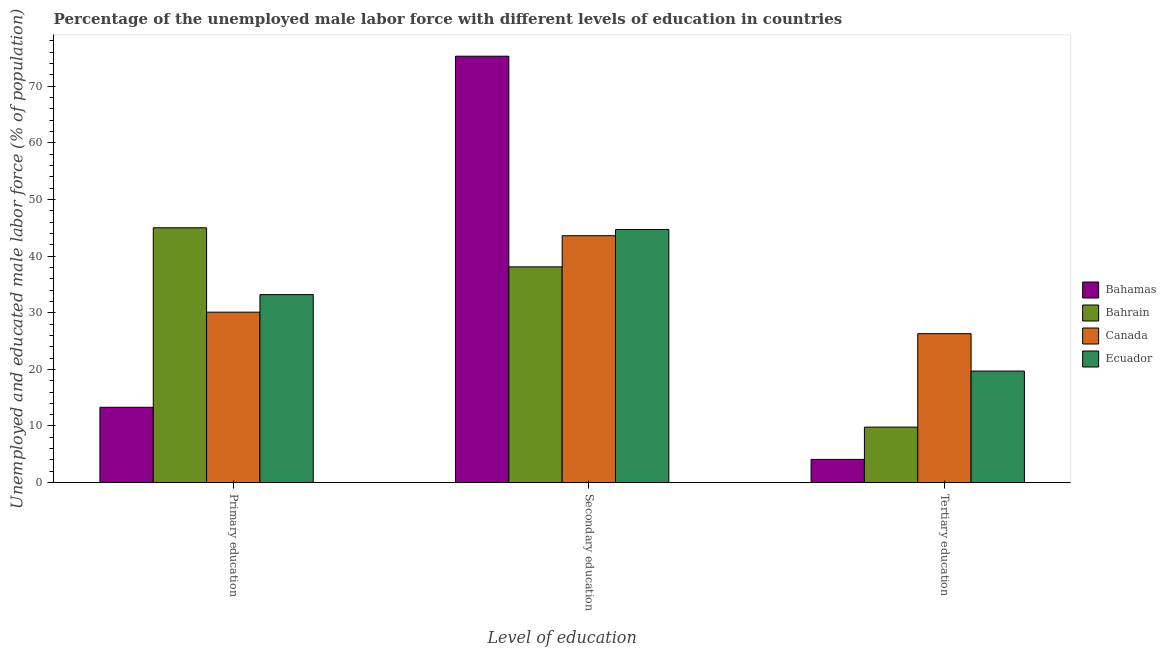How many different coloured bars are there?
Your answer should be very brief. 4. How many groups of bars are there?
Make the answer very short. 3. What is the percentage of male labor force who received tertiary education in Canada?
Your answer should be very brief. 26.3. Across all countries, what is the maximum percentage of male labor force who received secondary education?
Provide a short and direct response. 75.3. Across all countries, what is the minimum percentage of male labor force who received tertiary education?
Provide a succinct answer. 4.1. In which country was the percentage of male labor force who received secondary education maximum?
Provide a short and direct response. Bahamas. In which country was the percentage of male labor force who received tertiary education minimum?
Your answer should be very brief. Bahamas. What is the total percentage of male labor force who received secondary education in the graph?
Offer a terse response. 201.7. What is the difference between the percentage of male labor force who received tertiary education in Bahrain and that in Ecuador?
Your answer should be very brief. -9.9. What is the difference between the percentage of male labor force who received primary education in Ecuador and the percentage of male labor force who received secondary education in Bahamas?
Ensure brevity in your answer.  -42.1. What is the average percentage of male labor force who received secondary education per country?
Your answer should be compact. 50.43. What is the difference between the percentage of male labor force who received tertiary education and percentage of male labor force who received primary education in Canada?
Your answer should be very brief. -3.8. What is the ratio of the percentage of male labor force who received tertiary education in Canada to that in Bahamas?
Make the answer very short. 6.41. What is the difference between the highest and the second highest percentage of male labor force who received primary education?
Provide a short and direct response. 11.8. What is the difference between the highest and the lowest percentage of male labor force who received tertiary education?
Offer a very short reply. 22.2. In how many countries, is the percentage of male labor force who received tertiary education greater than the average percentage of male labor force who received tertiary education taken over all countries?
Your answer should be compact. 2. Is the sum of the percentage of male labor force who received primary education in Bahamas and Canada greater than the maximum percentage of male labor force who received tertiary education across all countries?
Provide a succinct answer. Yes. What does the 3rd bar from the left in Primary education represents?
Offer a very short reply. Canada. What does the 3rd bar from the right in Primary education represents?
Ensure brevity in your answer.  Bahrain. What is the difference between two consecutive major ticks on the Y-axis?
Ensure brevity in your answer.  10. Does the graph contain any zero values?
Your answer should be very brief. No. Where does the legend appear in the graph?
Ensure brevity in your answer.  Center right. How many legend labels are there?
Your answer should be compact. 4. How are the legend labels stacked?
Your answer should be compact. Vertical. What is the title of the graph?
Give a very brief answer. Percentage of the unemployed male labor force with different levels of education in countries. Does "Bahrain" appear as one of the legend labels in the graph?
Your answer should be very brief. Yes. What is the label or title of the X-axis?
Give a very brief answer. Level of education. What is the label or title of the Y-axis?
Your answer should be very brief. Unemployed and educated male labor force (% of population). What is the Unemployed and educated male labor force (% of population) of Bahamas in Primary education?
Your answer should be compact. 13.3. What is the Unemployed and educated male labor force (% of population) in Bahrain in Primary education?
Give a very brief answer. 45. What is the Unemployed and educated male labor force (% of population) in Canada in Primary education?
Offer a terse response. 30.1. What is the Unemployed and educated male labor force (% of population) in Ecuador in Primary education?
Ensure brevity in your answer.  33.2. What is the Unemployed and educated male labor force (% of population) in Bahamas in Secondary education?
Your answer should be compact. 75.3. What is the Unemployed and educated male labor force (% of population) of Bahrain in Secondary education?
Ensure brevity in your answer.  38.1. What is the Unemployed and educated male labor force (% of population) in Canada in Secondary education?
Your answer should be compact. 43.6. What is the Unemployed and educated male labor force (% of population) in Ecuador in Secondary education?
Keep it short and to the point. 44.7. What is the Unemployed and educated male labor force (% of population) in Bahamas in Tertiary education?
Your response must be concise. 4.1. What is the Unemployed and educated male labor force (% of population) of Bahrain in Tertiary education?
Keep it short and to the point. 9.8. What is the Unemployed and educated male labor force (% of population) of Canada in Tertiary education?
Your answer should be very brief. 26.3. What is the Unemployed and educated male labor force (% of population) of Ecuador in Tertiary education?
Offer a terse response. 19.7. Across all Level of education, what is the maximum Unemployed and educated male labor force (% of population) in Bahamas?
Your answer should be very brief. 75.3. Across all Level of education, what is the maximum Unemployed and educated male labor force (% of population) of Canada?
Ensure brevity in your answer.  43.6. Across all Level of education, what is the maximum Unemployed and educated male labor force (% of population) of Ecuador?
Your answer should be compact. 44.7. Across all Level of education, what is the minimum Unemployed and educated male labor force (% of population) of Bahamas?
Provide a short and direct response. 4.1. Across all Level of education, what is the minimum Unemployed and educated male labor force (% of population) in Bahrain?
Your answer should be compact. 9.8. Across all Level of education, what is the minimum Unemployed and educated male labor force (% of population) in Canada?
Make the answer very short. 26.3. Across all Level of education, what is the minimum Unemployed and educated male labor force (% of population) of Ecuador?
Ensure brevity in your answer.  19.7. What is the total Unemployed and educated male labor force (% of population) of Bahamas in the graph?
Keep it short and to the point. 92.7. What is the total Unemployed and educated male labor force (% of population) in Bahrain in the graph?
Provide a short and direct response. 92.9. What is the total Unemployed and educated male labor force (% of population) of Ecuador in the graph?
Your response must be concise. 97.6. What is the difference between the Unemployed and educated male labor force (% of population) in Bahamas in Primary education and that in Secondary education?
Your answer should be very brief. -62. What is the difference between the Unemployed and educated male labor force (% of population) of Bahrain in Primary education and that in Secondary education?
Give a very brief answer. 6.9. What is the difference between the Unemployed and educated male labor force (% of population) in Canada in Primary education and that in Secondary education?
Offer a very short reply. -13.5. What is the difference between the Unemployed and educated male labor force (% of population) in Bahamas in Primary education and that in Tertiary education?
Provide a succinct answer. 9.2. What is the difference between the Unemployed and educated male labor force (% of population) of Bahrain in Primary education and that in Tertiary education?
Offer a terse response. 35.2. What is the difference between the Unemployed and educated male labor force (% of population) of Bahamas in Secondary education and that in Tertiary education?
Keep it short and to the point. 71.2. What is the difference between the Unemployed and educated male labor force (% of population) in Bahrain in Secondary education and that in Tertiary education?
Your answer should be compact. 28.3. What is the difference between the Unemployed and educated male labor force (% of population) in Bahamas in Primary education and the Unemployed and educated male labor force (% of population) in Bahrain in Secondary education?
Make the answer very short. -24.8. What is the difference between the Unemployed and educated male labor force (% of population) in Bahamas in Primary education and the Unemployed and educated male labor force (% of population) in Canada in Secondary education?
Provide a short and direct response. -30.3. What is the difference between the Unemployed and educated male labor force (% of population) in Bahamas in Primary education and the Unemployed and educated male labor force (% of population) in Ecuador in Secondary education?
Make the answer very short. -31.4. What is the difference between the Unemployed and educated male labor force (% of population) in Bahrain in Primary education and the Unemployed and educated male labor force (% of population) in Ecuador in Secondary education?
Make the answer very short. 0.3. What is the difference between the Unemployed and educated male labor force (% of population) in Canada in Primary education and the Unemployed and educated male labor force (% of population) in Ecuador in Secondary education?
Provide a succinct answer. -14.6. What is the difference between the Unemployed and educated male labor force (% of population) in Bahamas in Primary education and the Unemployed and educated male labor force (% of population) in Bahrain in Tertiary education?
Give a very brief answer. 3.5. What is the difference between the Unemployed and educated male labor force (% of population) in Bahamas in Primary education and the Unemployed and educated male labor force (% of population) in Canada in Tertiary education?
Your answer should be very brief. -13. What is the difference between the Unemployed and educated male labor force (% of population) of Bahrain in Primary education and the Unemployed and educated male labor force (% of population) of Canada in Tertiary education?
Offer a terse response. 18.7. What is the difference between the Unemployed and educated male labor force (% of population) of Bahrain in Primary education and the Unemployed and educated male labor force (% of population) of Ecuador in Tertiary education?
Ensure brevity in your answer.  25.3. What is the difference between the Unemployed and educated male labor force (% of population) of Canada in Primary education and the Unemployed and educated male labor force (% of population) of Ecuador in Tertiary education?
Keep it short and to the point. 10.4. What is the difference between the Unemployed and educated male labor force (% of population) of Bahamas in Secondary education and the Unemployed and educated male labor force (% of population) of Bahrain in Tertiary education?
Provide a short and direct response. 65.5. What is the difference between the Unemployed and educated male labor force (% of population) in Bahamas in Secondary education and the Unemployed and educated male labor force (% of population) in Ecuador in Tertiary education?
Offer a very short reply. 55.6. What is the difference between the Unemployed and educated male labor force (% of population) of Bahrain in Secondary education and the Unemployed and educated male labor force (% of population) of Canada in Tertiary education?
Give a very brief answer. 11.8. What is the difference between the Unemployed and educated male labor force (% of population) in Canada in Secondary education and the Unemployed and educated male labor force (% of population) in Ecuador in Tertiary education?
Offer a very short reply. 23.9. What is the average Unemployed and educated male labor force (% of population) in Bahamas per Level of education?
Make the answer very short. 30.9. What is the average Unemployed and educated male labor force (% of population) of Bahrain per Level of education?
Your answer should be compact. 30.97. What is the average Unemployed and educated male labor force (% of population) in Canada per Level of education?
Keep it short and to the point. 33.33. What is the average Unemployed and educated male labor force (% of population) of Ecuador per Level of education?
Provide a succinct answer. 32.53. What is the difference between the Unemployed and educated male labor force (% of population) of Bahamas and Unemployed and educated male labor force (% of population) of Bahrain in Primary education?
Your answer should be compact. -31.7. What is the difference between the Unemployed and educated male labor force (% of population) of Bahamas and Unemployed and educated male labor force (% of population) of Canada in Primary education?
Give a very brief answer. -16.8. What is the difference between the Unemployed and educated male labor force (% of population) in Bahamas and Unemployed and educated male labor force (% of population) in Ecuador in Primary education?
Offer a terse response. -19.9. What is the difference between the Unemployed and educated male labor force (% of population) in Bahrain and Unemployed and educated male labor force (% of population) in Canada in Primary education?
Ensure brevity in your answer.  14.9. What is the difference between the Unemployed and educated male labor force (% of population) of Bahamas and Unemployed and educated male labor force (% of population) of Bahrain in Secondary education?
Make the answer very short. 37.2. What is the difference between the Unemployed and educated male labor force (% of population) of Bahamas and Unemployed and educated male labor force (% of population) of Canada in Secondary education?
Ensure brevity in your answer.  31.7. What is the difference between the Unemployed and educated male labor force (% of population) of Bahamas and Unemployed and educated male labor force (% of population) of Ecuador in Secondary education?
Give a very brief answer. 30.6. What is the difference between the Unemployed and educated male labor force (% of population) in Canada and Unemployed and educated male labor force (% of population) in Ecuador in Secondary education?
Give a very brief answer. -1.1. What is the difference between the Unemployed and educated male labor force (% of population) of Bahamas and Unemployed and educated male labor force (% of population) of Canada in Tertiary education?
Keep it short and to the point. -22.2. What is the difference between the Unemployed and educated male labor force (% of population) in Bahamas and Unemployed and educated male labor force (% of population) in Ecuador in Tertiary education?
Your answer should be very brief. -15.6. What is the difference between the Unemployed and educated male labor force (% of population) of Bahrain and Unemployed and educated male labor force (% of population) of Canada in Tertiary education?
Give a very brief answer. -16.5. What is the difference between the Unemployed and educated male labor force (% of population) of Bahrain and Unemployed and educated male labor force (% of population) of Ecuador in Tertiary education?
Provide a succinct answer. -9.9. What is the ratio of the Unemployed and educated male labor force (% of population) in Bahamas in Primary education to that in Secondary education?
Provide a short and direct response. 0.18. What is the ratio of the Unemployed and educated male labor force (% of population) of Bahrain in Primary education to that in Secondary education?
Make the answer very short. 1.18. What is the ratio of the Unemployed and educated male labor force (% of population) in Canada in Primary education to that in Secondary education?
Provide a short and direct response. 0.69. What is the ratio of the Unemployed and educated male labor force (% of population) in Ecuador in Primary education to that in Secondary education?
Offer a very short reply. 0.74. What is the ratio of the Unemployed and educated male labor force (% of population) in Bahamas in Primary education to that in Tertiary education?
Your answer should be compact. 3.24. What is the ratio of the Unemployed and educated male labor force (% of population) of Bahrain in Primary education to that in Tertiary education?
Offer a terse response. 4.59. What is the ratio of the Unemployed and educated male labor force (% of population) in Canada in Primary education to that in Tertiary education?
Keep it short and to the point. 1.14. What is the ratio of the Unemployed and educated male labor force (% of population) of Ecuador in Primary education to that in Tertiary education?
Keep it short and to the point. 1.69. What is the ratio of the Unemployed and educated male labor force (% of population) of Bahamas in Secondary education to that in Tertiary education?
Offer a terse response. 18.37. What is the ratio of the Unemployed and educated male labor force (% of population) of Bahrain in Secondary education to that in Tertiary education?
Your answer should be compact. 3.89. What is the ratio of the Unemployed and educated male labor force (% of population) in Canada in Secondary education to that in Tertiary education?
Your answer should be compact. 1.66. What is the ratio of the Unemployed and educated male labor force (% of population) of Ecuador in Secondary education to that in Tertiary education?
Your answer should be compact. 2.27. What is the difference between the highest and the second highest Unemployed and educated male labor force (% of population) in Canada?
Offer a terse response. 13.5. What is the difference between the highest and the second highest Unemployed and educated male labor force (% of population) of Ecuador?
Keep it short and to the point. 11.5. What is the difference between the highest and the lowest Unemployed and educated male labor force (% of population) of Bahamas?
Your answer should be very brief. 71.2. What is the difference between the highest and the lowest Unemployed and educated male labor force (% of population) in Bahrain?
Offer a terse response. 35.2. What is the difference between the highest and the lowest Unemployed and educated male labor force (% of population) of Canada?
Your answer should be very brief. 17.3. What is the difference between the highest and the lowest Unemployed and educated male labor force (% of population) of Ecuador?
Your answer should be very brief. 25. 